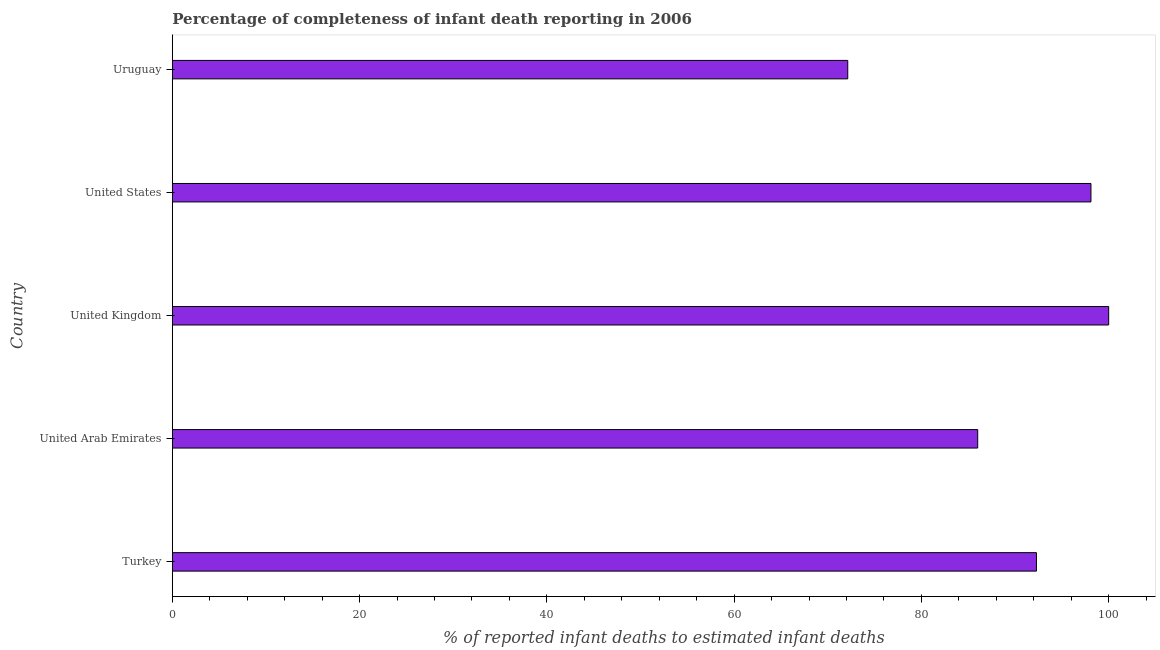What is the title of the graph?
Your response must be concise. Percentage of completeness of infant death reporting in 2006. What is the label or title of the X-axis?
Give a very brief answer. % of reported infant deaths to estimated infant deaths. What is the label or title of the Y-axis?
Give a very brief answer. Country. Across all countries, what is the maximum completeness of infant death reporting?
Your response must be concise. 100. Across all countries, what is the minimum completeness of infant death reporting?
Make the answer very short. 72.13. In which country was the completeness of infant death reporting minimum?
Keep it short and to the point. Uruguay. What is the sum of the completeness of infant death reporting?
Ensure brevity in your answer.  448.54. What is the difference between the completeness of infant death reporting in Turkey and United States?
Ensure brevity in your answer.  -5.82. What is the average completeness of infant death reporting per country?
Your answer should be very brief. 89.71. What is the median completeness of infant death reporting?
Make the answer very short. 92.29. In how many countries, is the completeness of infant death reporting greater than 72 %?
Provide a short and direct response. 5. What is the ratio of the completeness of infant death reporting in Turkey to that in United Kingdom?
Make the answer very short. 0.92. Is the completeness of infant death reporting in Turkey less than that in United States?
Offer a very short reply. Yes. Is the difference between the completeness of infant death reporting in Turkey and Uruguay greater than the difference between any two countries?
Your response must be concise. No. What is the difference between the highest and the second highest completeness of infant death reporting?
Provide a short and direct response. 1.89. What is the difference between the highest and the lowest completeness of infant death reporting?
Offer a very short reply. 27.87. In how many countries, is the completeness of infant death reporting greater than the average completeness of infant death reporting taken over all countries?
Your answer should be compact. 3. What is the difference between two consecutive major ticks on the X-axis?
Your response must be concise. 20. What is the % of reported infant deaths to estimated infant deaths of Turkey?
Provide a short and direct response. 92.29. What is the % of reported infant deaths to estimated infant deaths of United Arab Emirates?
Your response must be concise. 86.01. What is the % of reported infant deaths to estimated infant deaths in United Kingdom?
Provide a succinct answer. 100. What is the % of reported infant deaths to estimated infant deaths in United States?
Your answer should be compact. 98.11. What is the % of reported infant deaths to estimated infant deaths of Uruguay?
Ensure brevity in your answer.  72.13. What is the difference between the % of reported infant deaths to estimated infant deaths in Turkey and United Arab Emirates?
Provide a short and direct response. 6.27. What is the difference between the % of reported infant deaths to estimated infant deaths in Turkey and United Kingdom?
Your response must be concise. -7.71. What is the difference between the % of reported infant deaths to estimated infant deaths in Turkey and United States?
Ensure brevity in your answer.  -5.82. What is the difference between the % of reported infant deaths to estimated infant deaths in Turkey and Uruguay?
Your answer should be compact. 20.15. What is the difference between the % of reported infant deaths to estimated infant deaths in United Arab Emirates and United Kingdom?
Make the answer very short. -13.99. What is the difference between the % of reported infant deaths to estimated infant deaths in United Arab Emirates and United States?
Provide a short and direct response. -12.1. What is the difference between the % of reported infant deaths to estimated infant deaths in United Arab Emirates and Uruguay?
Your answer should be very brief. 13.88. What is the difference between the % of reported infant deaths to estimated infant deaths in United Kingdom and United States?
Provide a succinct answer. 1.89. What is the difference between the % of reported infant deaths to estimated infant deaths in United Kingdom and Uruguay?
Your answer should be very brief. 27.87. What is the difference between the % of reported infant deaths to estimated infant deaths in United States and Uruguay?
Your answer should be compact. 25.97. What is the ratio of the % of reported infant deaths to estimated infant deaths in Turkey to that in United Arab Emirates?
Make the answer very short. 1.07. What is the ratio of the % of reported infant deaths to estimated infant deaths in Turkey to that in United Kingdom?
Keep it short and to the point. 0.92. What is the ratio of the % of reported infant deaths to estimated infant deaths in Turkey to that in United States?
Provide a short and direct response. 0.94. What is the ratio of the % of reported infant deaths to estimated infant deaths in Turkey to that in Uruguay?
Provide a succinct answer. 1.28. What is the ratio of the % of reported infant deaths to estimated infant deaths in United Arab Emirates to that in United Kingdom?
Keep it short and to the point. 0.86. What is the ratio of the % of reported infant deaths to estimated infant deaths in United Arab Emirates to that in United States?
Provide a succinct answer. 0.88. What is the ratio of the % of reported infant deaths to estimated infant deaths in United Arab Emirates to that in Uruguay?
Your answer should be very brief. 1.19. What is the ratio of the % of reported infant deaths to estimated infant deaths in United Kingdom to that in United States?
Give a very brief answer. 1.02. What is the ratio of the % of reported infant deaths to estimated infant deaths in United Kingdom to that in Uruguay?
Provide a succinct answer. 1.39. What is the ratio of the % of reported infant deaths to estimated infant deaths in United States to that in Uruguay?
Provide a succinct answer. 1.36. 